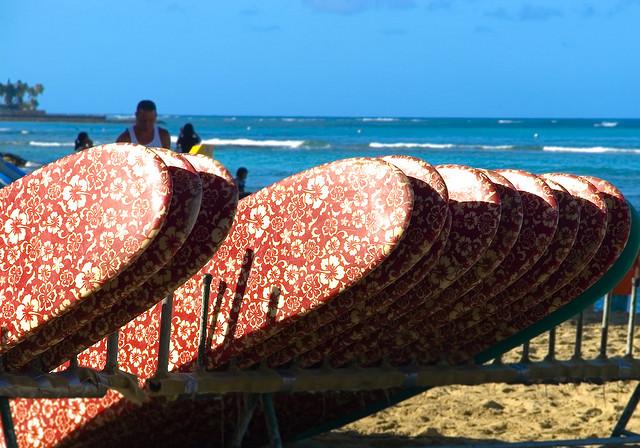How many surfboards are in the picture?
Quick response, please. 12. What number of bars make up the rack?
Concise answer only. 20. How many people can be seen?
Quick response, please. 4. 